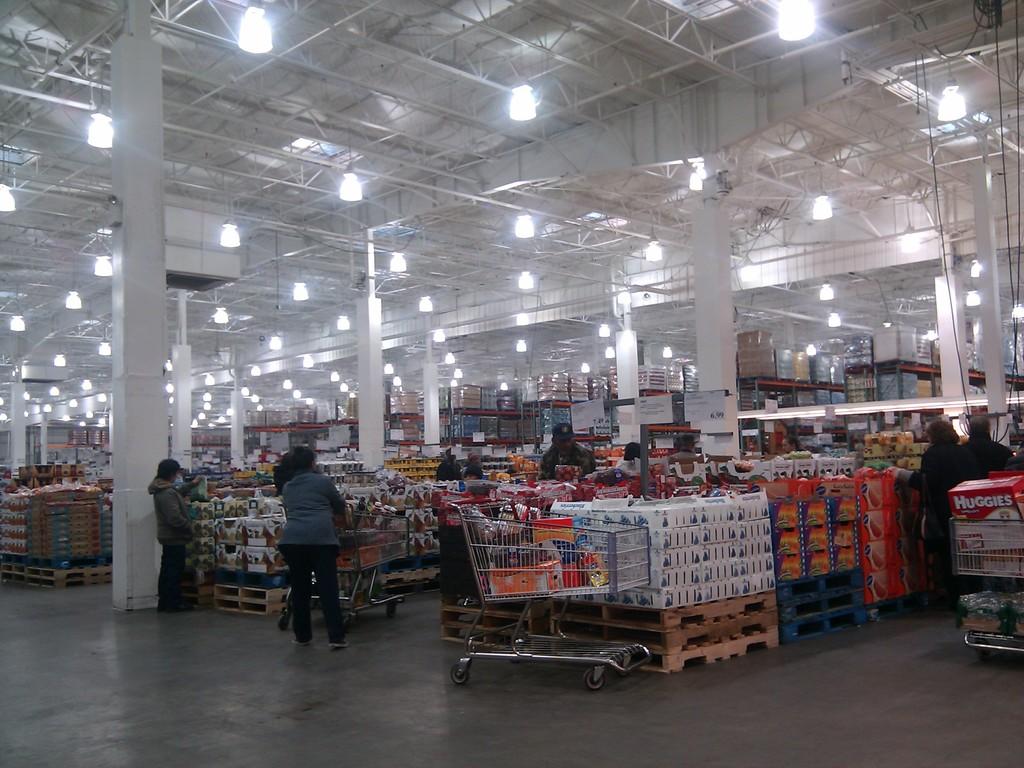What kind of product is the red box on the right?
Provide a succinct answer. Huggies. 